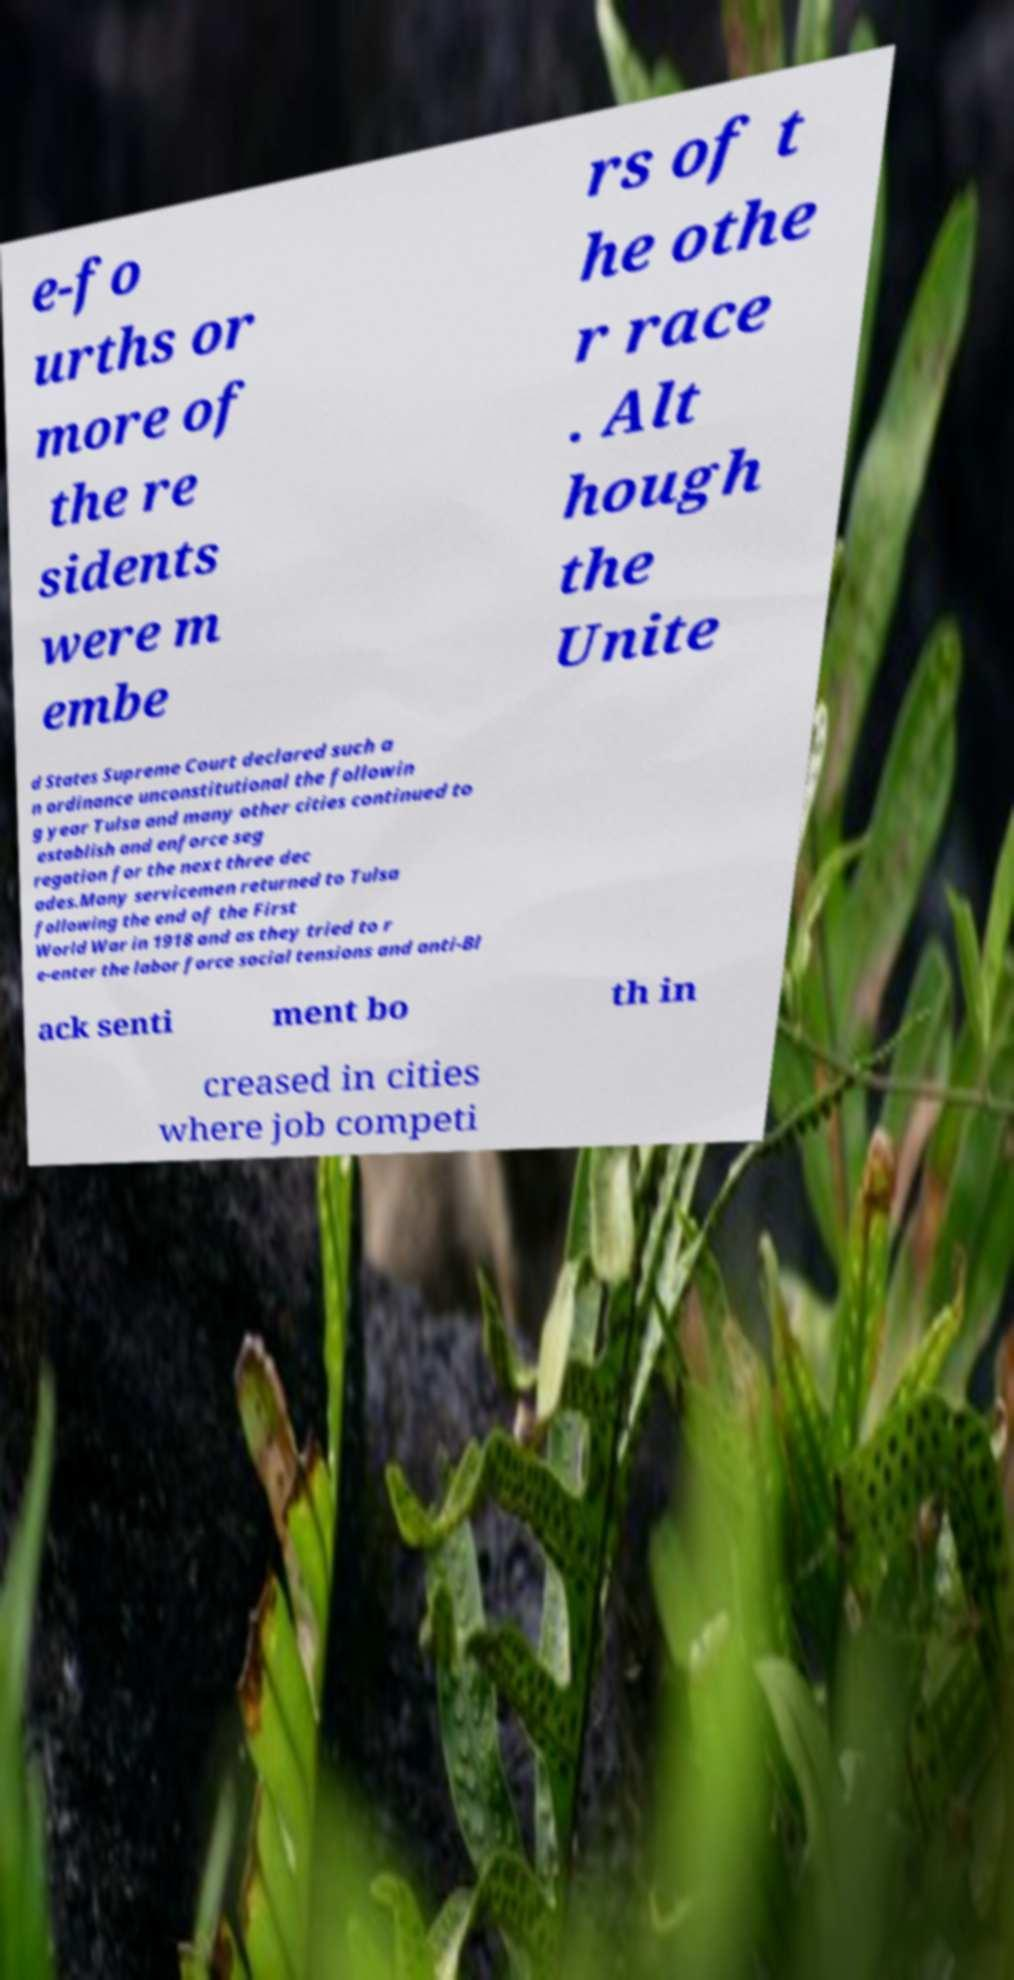What messages or text are displayed in this image? I need them in a readable, typed format. e-fo urths or more of the re sidents were m embe rs of t he othe r race . Alt hough the Unite d States Supreme Court declared such a n ordinance unconstitutional the followin g year Tulsa and many other cities continued to establish and enforce seg regation for the next three dec ades.Many servicemen returned to Tulsa following the end of the First World War in 1918 and as they tried to r e-enter the labor force social tensions and anti-Bl ack senti ment bo th in creased in cities where job competi 